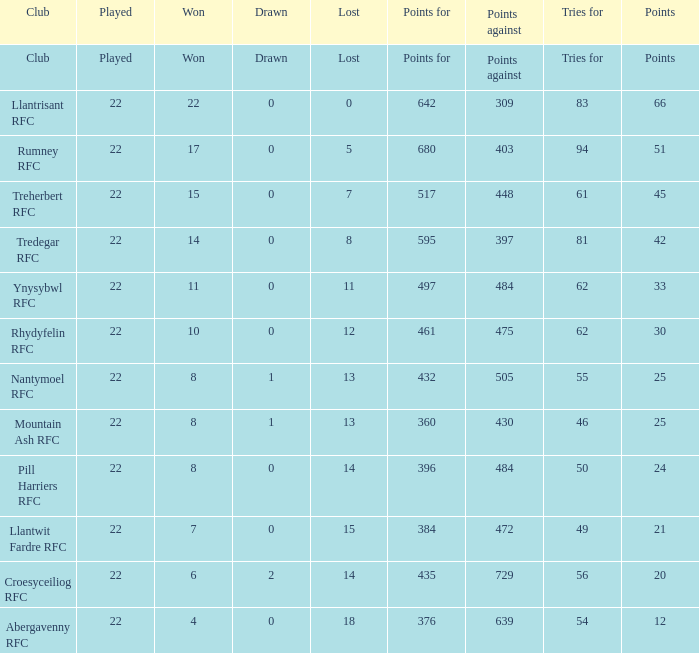For teams that won exactly 15, how many points were scored? 45.0. 